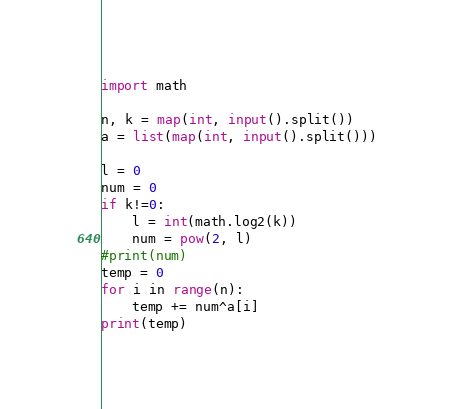Convert code to text. <code><loc_0><loc_0><loc_500><loc_500><_Python_>import math

n, k = map(int, input().split())
a = list(map(int, input().split()))

l = 0
num = 0
if k!=0:
	l = int(math.log2(k))
	num = pow(2, l)
#print(num)
temp = 0
for i in range(n):
	temp += num^a[i]
print(temp)</code> 